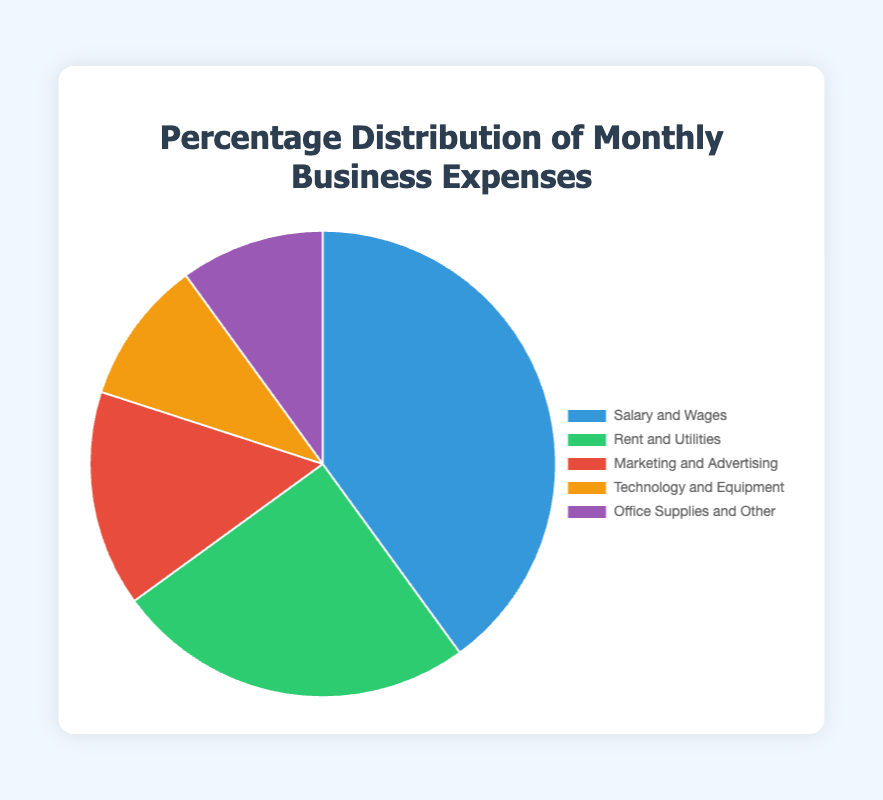Which expense category has the highest percentage in the pie chart? The expense category with the highest percentage is visually the largest section of the pie chart, which corresponds to 'Salary and Wages' with 40%.
Answer: Salary and Wages What is the combined percentage for 'Technology and Equipment' and 'Office Supplies and Other'? Add the percentages for 'Technology and Equipment' (10%) and 'Office Supplies and Other' (10%): 10% + 10% = 20%.
Answer: 20% Which category has a higher percentage: 'Rent and Utilities' or 'Marketing and Advertising'? Compare the percentages: 'Rent and Utilities' is 25% while 'Marketing and Advertising' is 15%, so 'Rent and Utilities' has a higher percentage.
Answer: Rent and Utilities What percentage of the expenses is not attributed to 'Salary and Wages'? Subtract the percentage for 'Salary and Wages' from 100%: 100% - 40% = 60%.
Answer: 60% Which category is represented by the green segment of the pie chart? The green segment, being the second largest, corresponds to 'Rent and Utilities' with 25%.
Answer: Rent and Utilities What is the average percentage of all five expense categories? Sum all percentages (40% + 25% + 15% + 10% + 10% = 100%) and divide by the number of categories (5): 100% / 5 = 20%.
Answer: 20% If the categories 'Technology and Equipment' and 'Office Supplies and Other' were combined, would their total percentage be greater than that of 'Marketing and Advertising'? Add the percentages of 'Technology and Equipment' (10%) and 'Office Supplies and Other' (10%) to get 20%, which is greater than 'Marketing and Advertising' at 15%.
Answer: Yes Which category has the smallest percentage, and what percentage is it? The pie chart shows that both 'Technology and Equipment' and 'Office Supplies and Other' have the smallest percentage, each at 10%.
Answer: Technology and Equipment, Office Supplies and Other (10%) How much higher is the percentage for 'Salary and Wages' compared to 'Marketing and Advertising'? Subtract the percentage of 'Marketing and Advertising' (15%) from 'Salary and Wages' (40%): 40% - 15% = 25%.
Answer: 25% What is the second smallest category in terms of percentage? The second smallest category in terms of percentage in the pie chart is 'Marketing and Advertising' with 15%.
Answer: Marketing and Advertising 